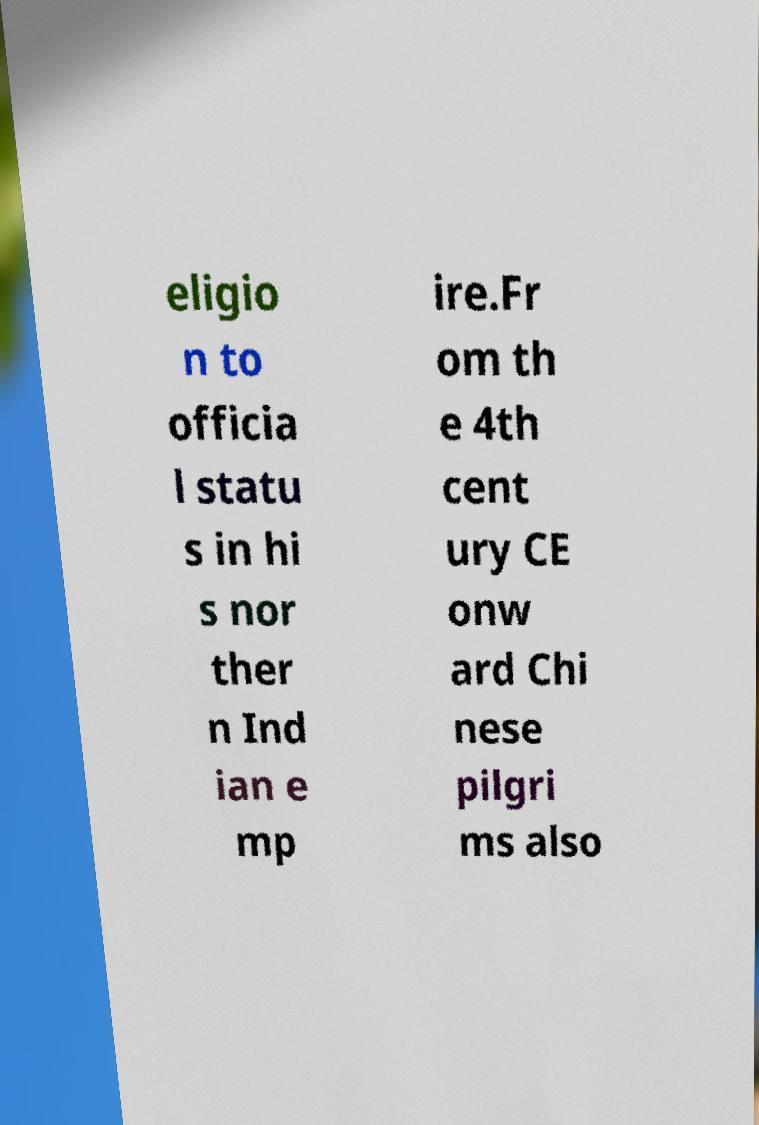Can you accurately transcribe the text from the provided image for me? eligio n to officia l statu s in hi s nor ther n Ind ian e mp ire.Fr om th e 4th cent ury CE onw ard Chi nese pilgri ms also 